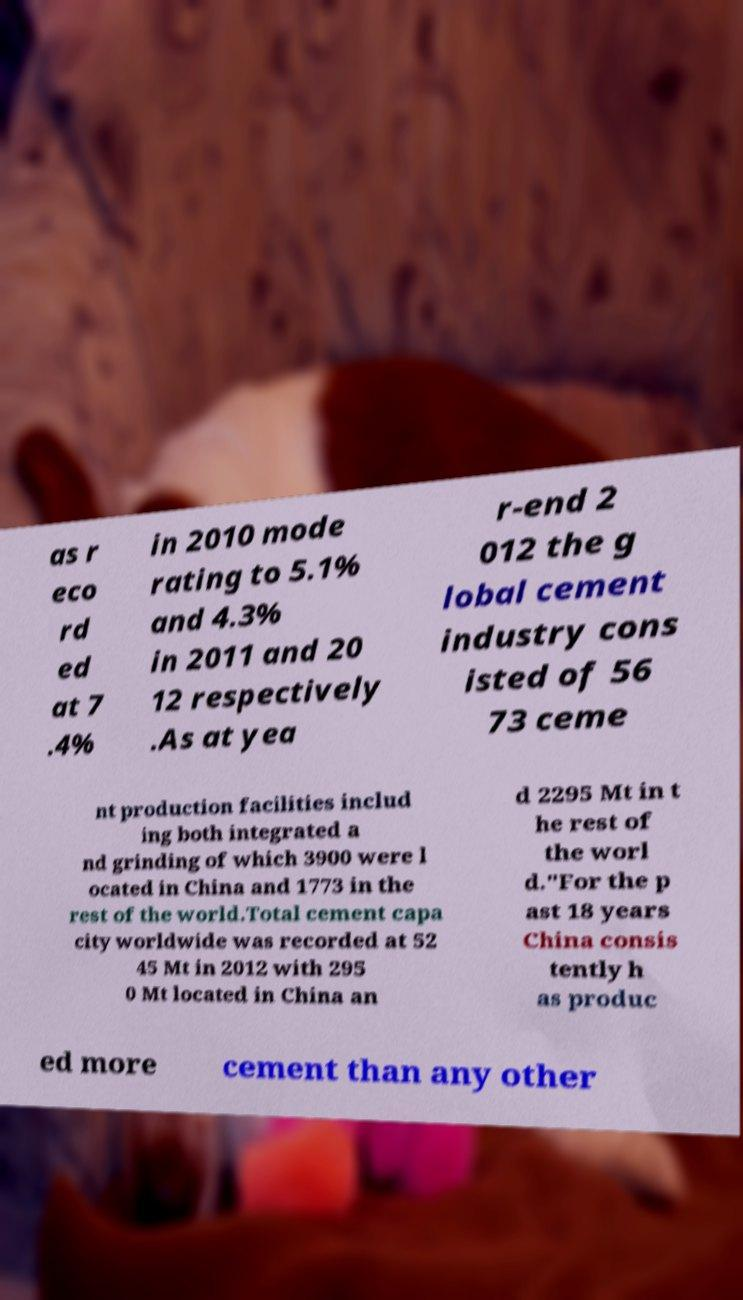Please read and relay the text visible in this image. What does it say? as r eco rd ed at 7 .4% in 2010 mode rating to 5.1% and 4.3% in 2011 and 20 12 respectively .As at yea r-end 2 012 the g lobal cement industry cons isted of 56 73 ceme nt production facilities includ ing both integrated a nd grinding of which 3900 were l ocated in China and 1773 in the rest of the world.Total cement capa city worldwide was recorded at 52 45 Mt in 2012 with 295 0 Mt located in China an d 2295 Mt in t he rest of the worl d."For the p ast 18 years China consis tently h as produc ed more cement than any other 